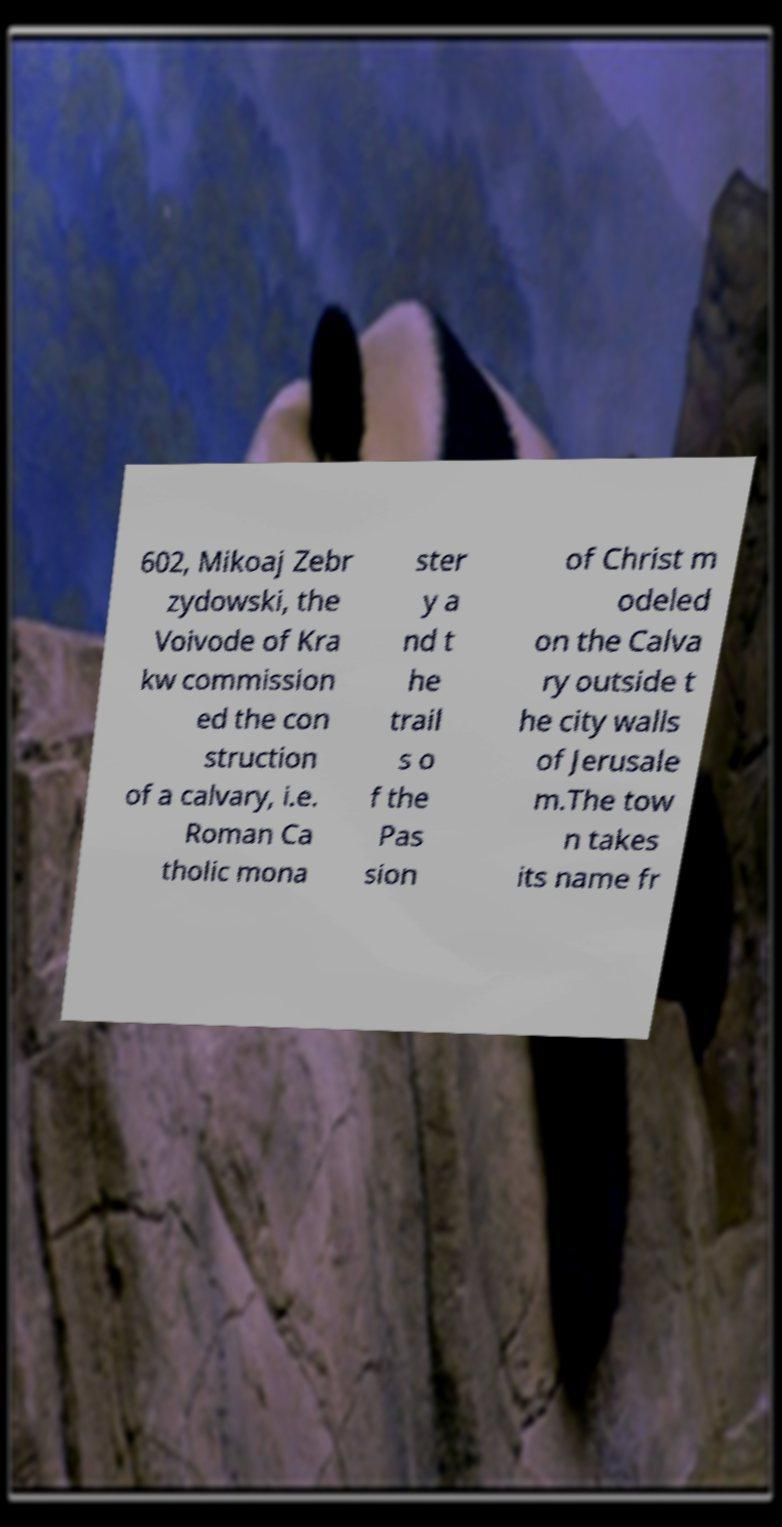Could you extract and type out the text from this image? 602, Mikoaj Zebr zydowski, the Voivode of Kra kw commission ed the con struction of a calvary, i.e. Roman Ca tholic mona ster y a nd t he trail s o f the Pas sion of Christ m odeled on the Calva ry outside t he city walls of Jerusale m.The tow n takes its name fr 